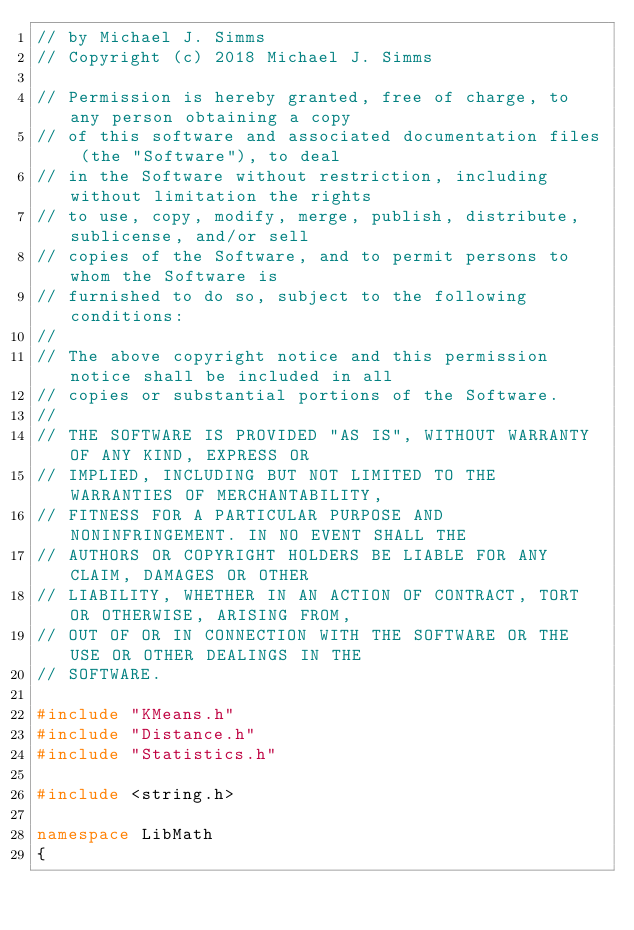Convert code to text. <code><loc_0><loc_0><loc_500><loc_500><_C++_>// by Michael J. Simms
// Copyright (c) 2018 Michael J. Simms

// Permission is hereby granted, free of charge, to any person obtaining a copy
// of this software and associated documentation files (the "Software"), to deal
// in the Software without restriction, including without limitation the rights
// to use, copy, modify, merge, publish, distribute, sublicense, and/or sell
// copies of the Software, and to permit persons to whom the Software is
// furnished to do so, subject to the following conditions:
// 
// The above copyright notice and this permission notice shall be included in all
// copies or substantial portions of the Software.
// 
// THE SOFTWARE IS PROVIDED "AS IS", WITHOUT WARRANTY OF ANY KIND, EXPRESS OR
// IMPLIED, INCLUDING BUT NOT LIMITED TO THE WARRANTIES OF MERCHANTABILITY,
// FITNESS FOR A PARTICULAR PURPOSE AND NONINFRINGEMENT. IN NO EVENT SHALL THE
// AUTHORS OR COPYRIGHT HOLDERS BE LIABLE FOR ANY CLAIM, DAMAGES OR OTHER
// LIABILITY, WHETHER IN AN ACTION OF CONTRACT, TORT OR OTHERWISE, ARISING FROM,
// OUT OF OR IN CONNECTION WITH THE SOFTWARE OR THE USE OR OTHER DEALINGS IN THE
// SOFTWARE.

#include "KMeans.h"
#include "Distance.h"
#include "Statistics.h"

#include <string.h>

namespace LibMath
{</code> 